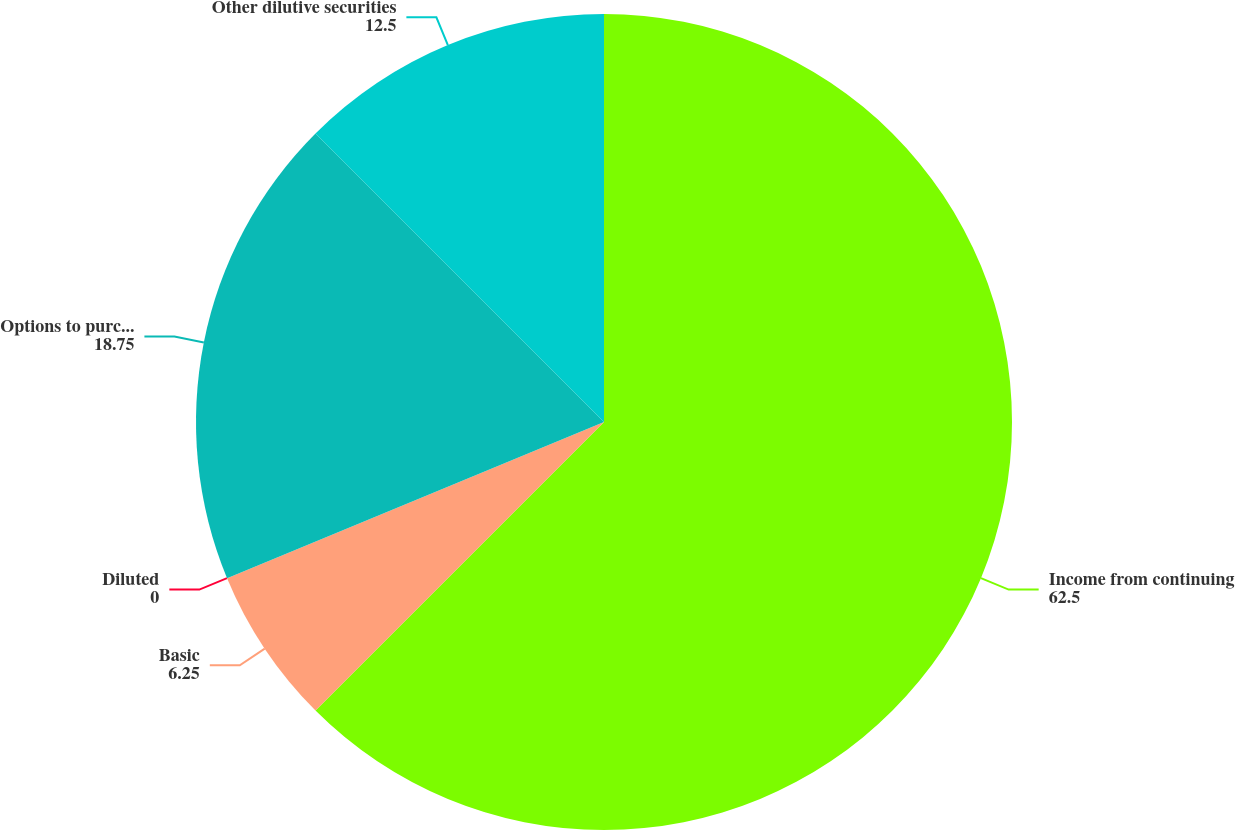Convert chart to OTSL. <chart><loc_0><loc_0><loc_500><loc_500><pie_chart><fcel>Income from continuing<fcel>Basic<fcel>Diluted<fcel>Options to purchase common<fcel>Other dilutive securities<nl><fcel>62.5%<fcel>6.25%<fcel>0.0%<fcel>18.75%<fcel>12.5%<nl></chart> 